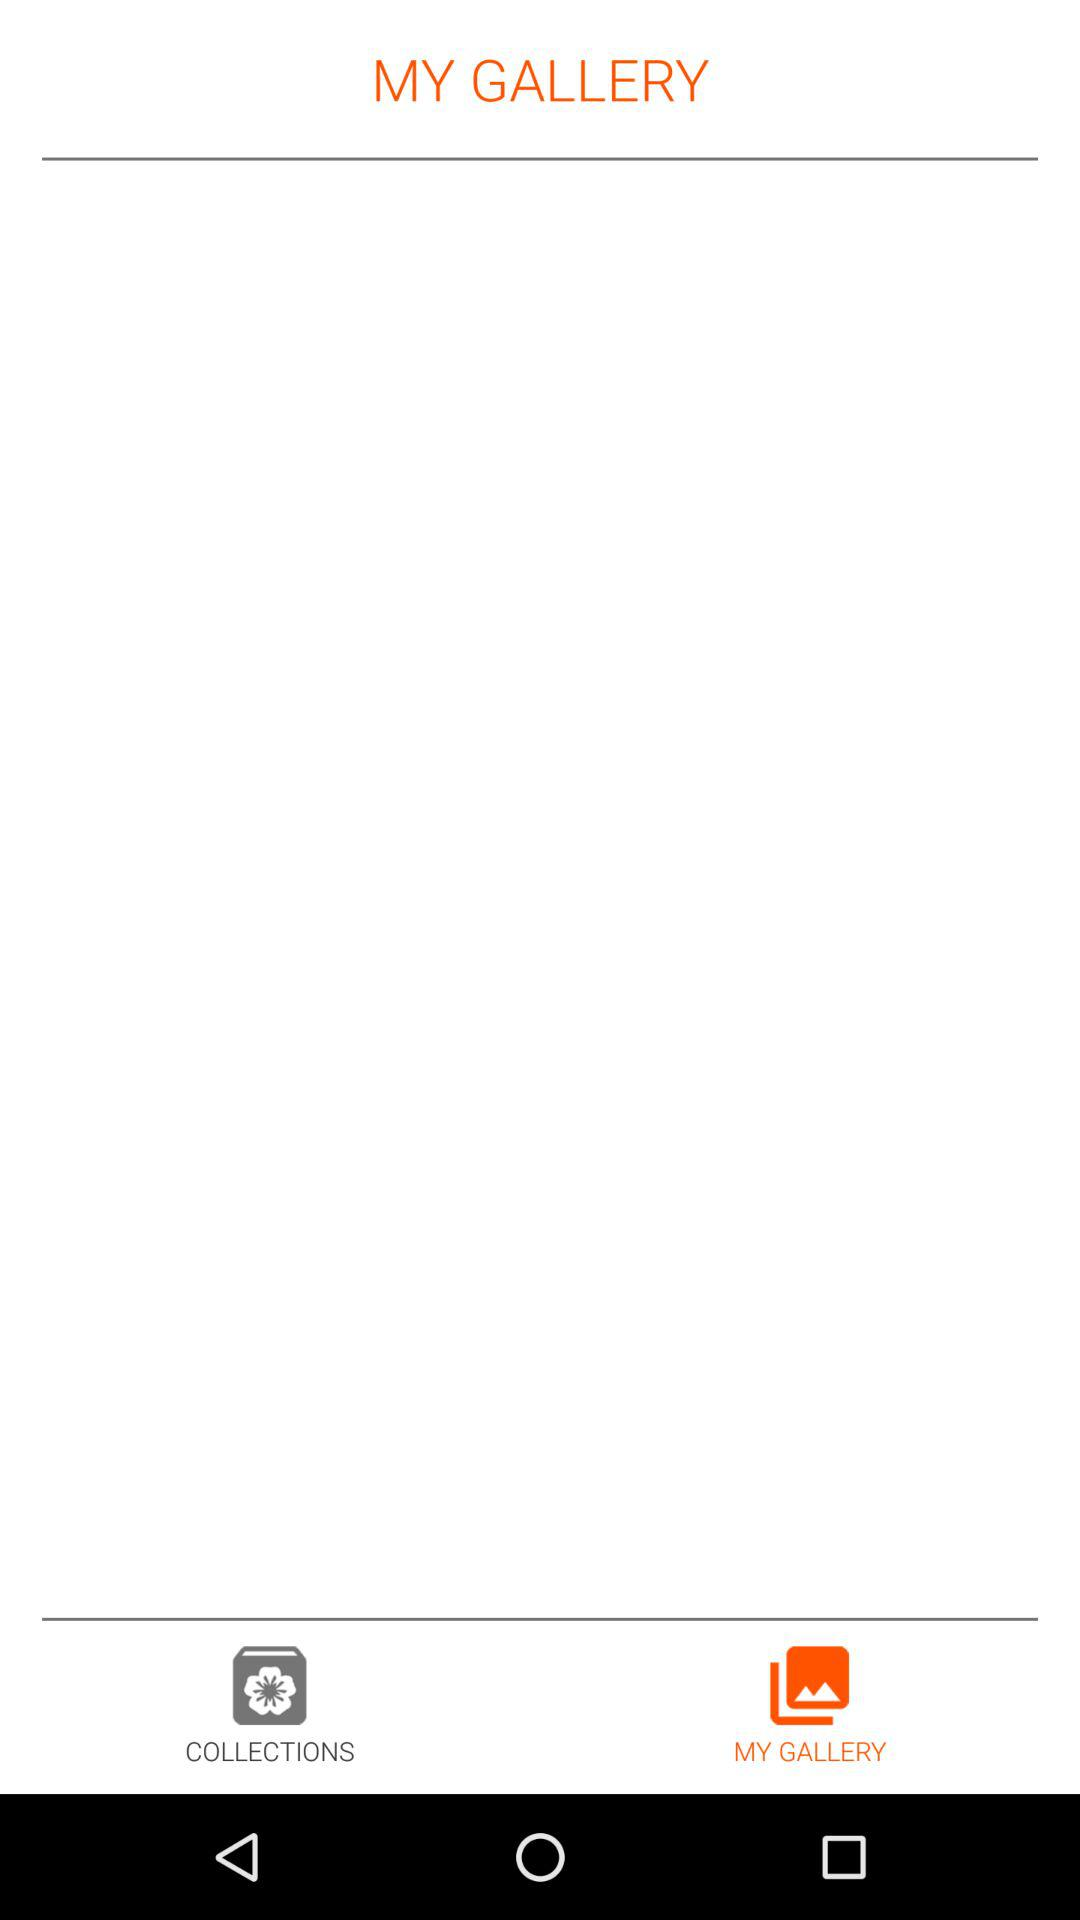Which tab is selected? The selected tab is "MY GALLERY". 